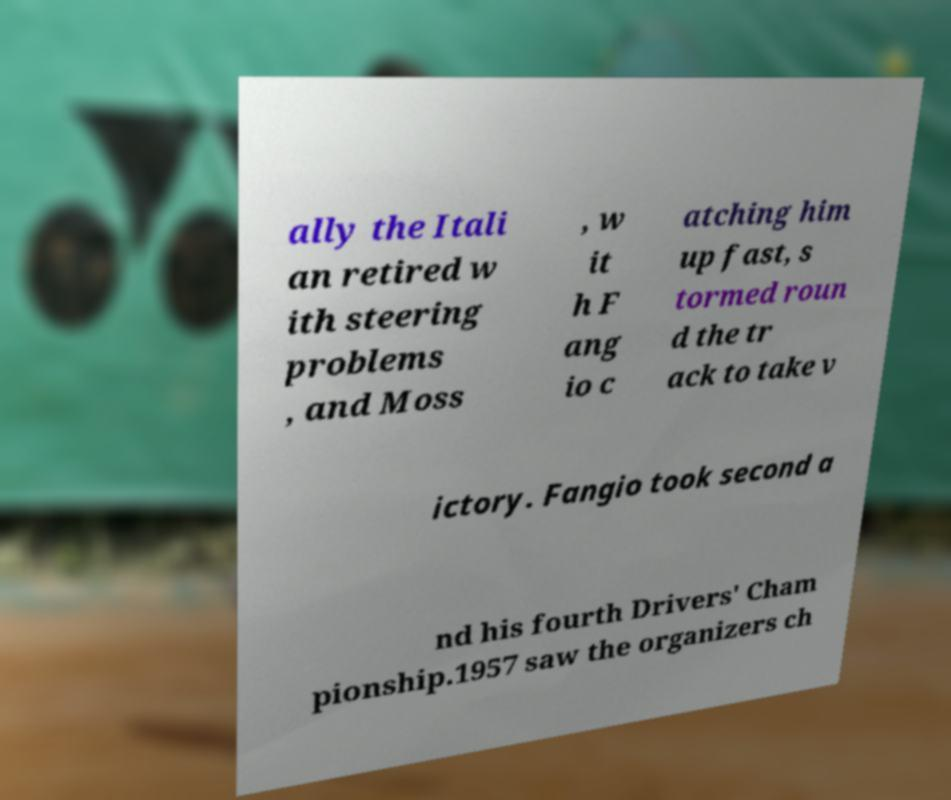What messages or text are displayed in this image? I need them in a readable, typed format. ally the Itali an retired w ith steering problems , and Moss , w it h F ang io c atching him up fast, s tormed roun d the tr ack to take v ictory. Fangio took second a nd his fourth Drivers' Cham pionship.1957 saw the organizers ch 